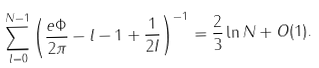Convert formula to latex. <formula><loc_0><loc_0><loc_500><loc_500>\sum ^ { N - 1 } _ { l = 0 } \left ( \frac { e \Phi } { 2 \pi } - l - 1 + \frac { 1 } { 2 I } \right ) ^ { - 1 } = \frac { 2 } { 3 } \ln N + O ( 1 ) .</formula> 